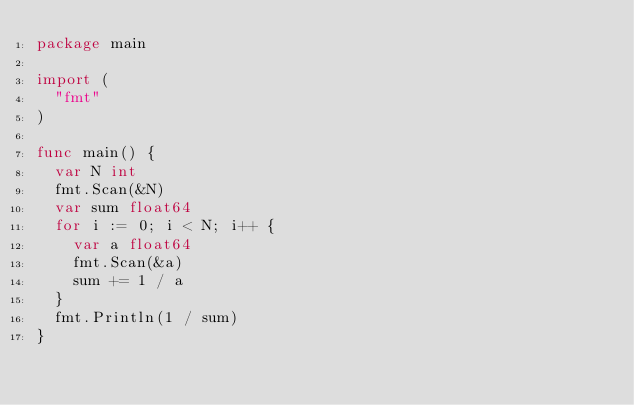<code> <loc_0><loc_0><loc_500><loc_500><_Go_>package main

import (
	"fmt"
)

func main() {
	var N int
	fmt.Scan(&N)
	var sum float64
	for i := 0; i < N; i++ {
		var a float64
		fmt.Scan(&a)
		sum += 1 / a
	}
	fmt.Println(1 / sum)
}
</code> 